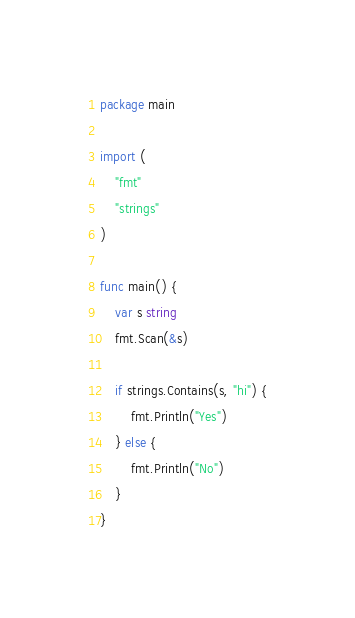<code> <loc_0><loc_0><loc_500><loc_500><_Go_>package main
 
import (
	"fmt"
	"strings"
)
 
func main() {
	var s string
	fmt.Scan(&s)
 
	if strings.Contains(s, "hi") {
		fmt.Println("Yes")
	} else {
		fmt.Println("No")
	}
}</code> 